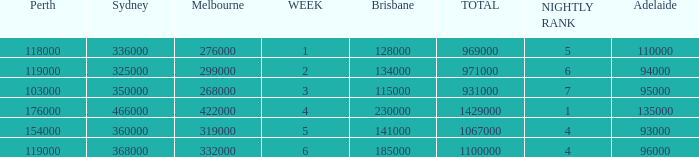What was the rating in Brisbane the week it was 276000 in Melbourne?  128000.0. 